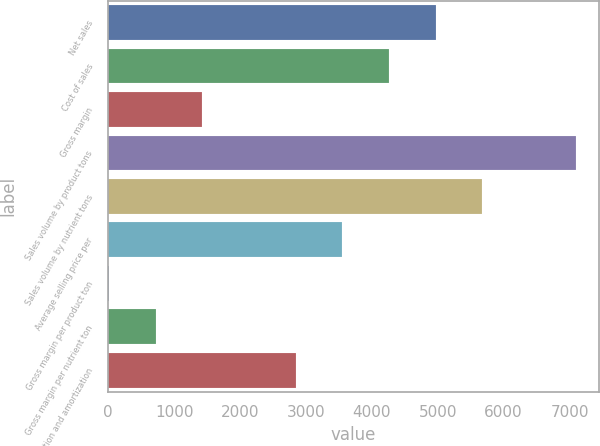<chart> <loc_0><loc_0><loc_500><loc_500><bar_chart><fcel>Net sales<fcel>Cost of sales<fcel>Gross margin<fcel>Sales volume by product tons<fcel>Sales volume by nutrient tons<fcel>Average selling price per<fcel>Gross margin per product ton<fcel>Gross margin per nutrient ton<fcel>Depreciation and amortization<nl><fcel>4968.4<fcel>4260.2<fcel>1427.4<fcel>7093<fcel>5676.6<fcel>3552<fcel>11<fcel>719.2<fcel>2843.8<nl></chart> 